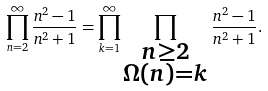<formula> <loc_0><loc_0><loc_500><loc_500>\prod _ { n = 2 } ^ { \infty } \frac { n ^ { 2 } - 1 } { n ^ { 2 } + 1 } = \prod _ { k = 1 } ^ { \infty } \prod _ { \substack { n \geq 2 \\ \Omega ( n ) = k } } \frac { n ^ { 2 } - 1 } { n ^ { 2 } + 1 } .</formula> 